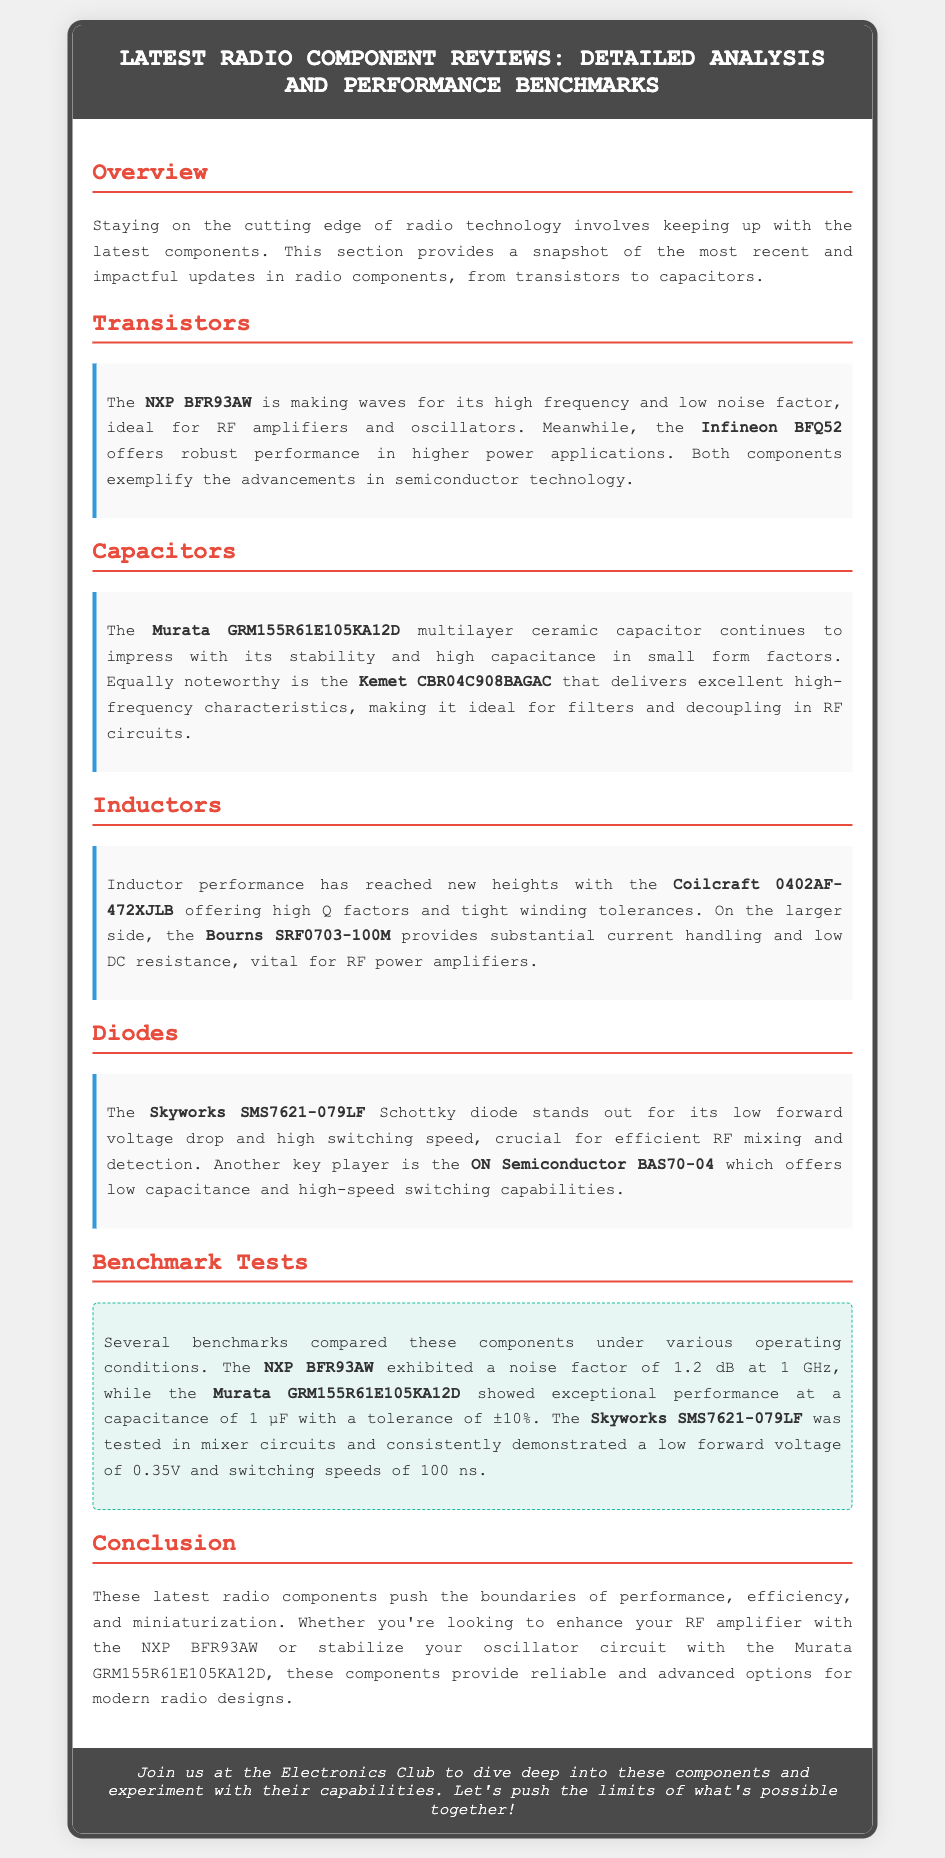What is the component discussed in the Transistors section? The component discussed is the NXP BFR93AW and Infineon BFQ52.
Answer: NXP BFR93AW, Infineon BFQ52 What is the capacitance of the Murata capacitor? The capacitance of the Murata capacitor is 1 µF.
Answer: 1 µF What is the noise factor exhibited by the NXP BFR93AW? The noise factor exhibited by the NXP BFR93AW is 1.2 dB at 1 GHz.
Answer: 1.2 dB Which component is known for low forward voltage and high switching speed? The Skyworks SMS7621-079LF Schottky diode is known for this.
Answer: Skyworks SMS7621-079LF What are the high-frequency characteristics of the Kemet capacitor? The Kemet capacitor delivers excellent high-frequency characteristics.
Answer: Excellent high-frequency characteristics What component is highlighted for substantial current handling? The component highlighted for substantial current handling is the Bourns SRF0703-100M.
Answer: Bourns SRF0703-100M What type of benchmarks were performed on the components? Several benchmarks compared these components under various operating conditions.
Answer: Various operating conditions Which capacitor has a tolerance of ±10%? The Murata GRM155R61E105KA12D capacitor has this tolerance.
Answer: ±10% What is the main focus of the document? The main focus is to provide a detailed analysis and performance benchmarks of latest radio components.
Answer: Detailed analysis and performance benchmarks of latest radio components 